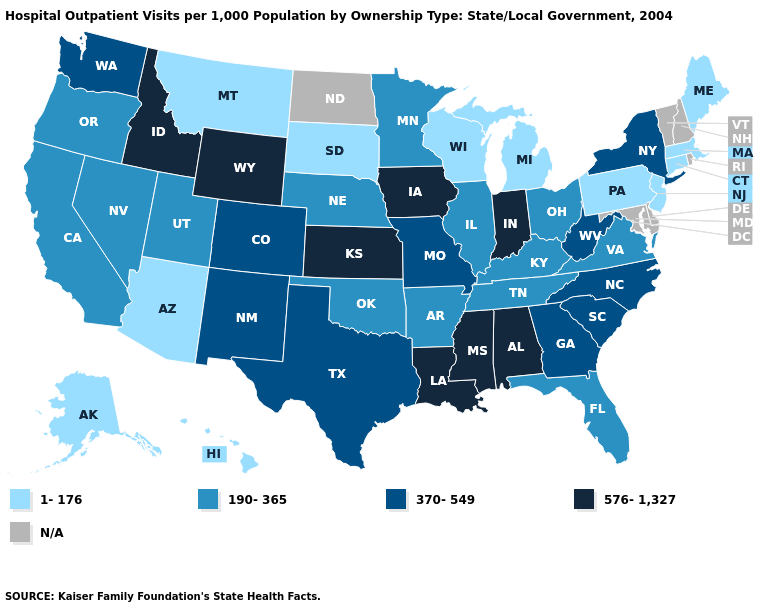What is the value of Iowa?
Answer briefly. 576-1,327. Name the states that have a value in the range 190-365?
Keep it brief. Arkansas, California, Florida, Illinois, Kentucky, Minnesota, Nebraska, Nevada, Ohio, Oklahoma, Oregon, Tennessee, Utah, Virginia. Which states have the highest value in the USA?
Give a very brief answer. Alabama, Idaho, Indiana, Iowa, Kansas, Louisiana, Mississippi, Wyoming. Does the first symbol in the legend represent the smallest category?
Answer briefly. Yes. Which states have the lowest value in the South?
Short answer required. Arkansas, Florida, Kentucky, Oklahoma, Tennessee, Virginia. Which states have the lowest value in the MidWest?
Concise answer only. Michigan, South Dakota, Wisconsin. What is the highest value in the USA?
Quick response, please. 576-1,327. Which states have the highest value in the USA?
Be succinct. Alabama, Idaho, Indiana, Iowa, Kansas, Louisiana, Mississippi, Wyoming. Which states hav the highest value in the Northeast?
Concise answer only. New York. Name the states that have a value in the range 1-176?
Keep it brief. Alaska, Arizona, Connecticut, Hawaii, Maine, Massachusetts, Michigan, Montana, New Jersey, Pennsylvania, South Dakota, Wisconsin. Is the legend a continuous bar?
Short answer required. No. What is the highest value in states that border Arkansas?
Concise answer only. 576-1,327. Does Connecticut have the lowest value in the USA?
Be succinct. Yes. What is the highest value in the USA?
Keep it brief. 576-1,327. 